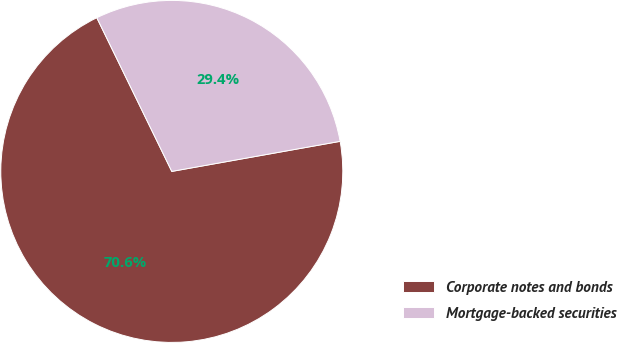Convert chart. <chart><loc_0><loc_0><loc_500><loc_500><pie_chart><fcel>Corporate notes and bonds<fcel>Mortgage-backed securities<nl><fcel>70.59%<fcel>29.41%<nl></chart> 